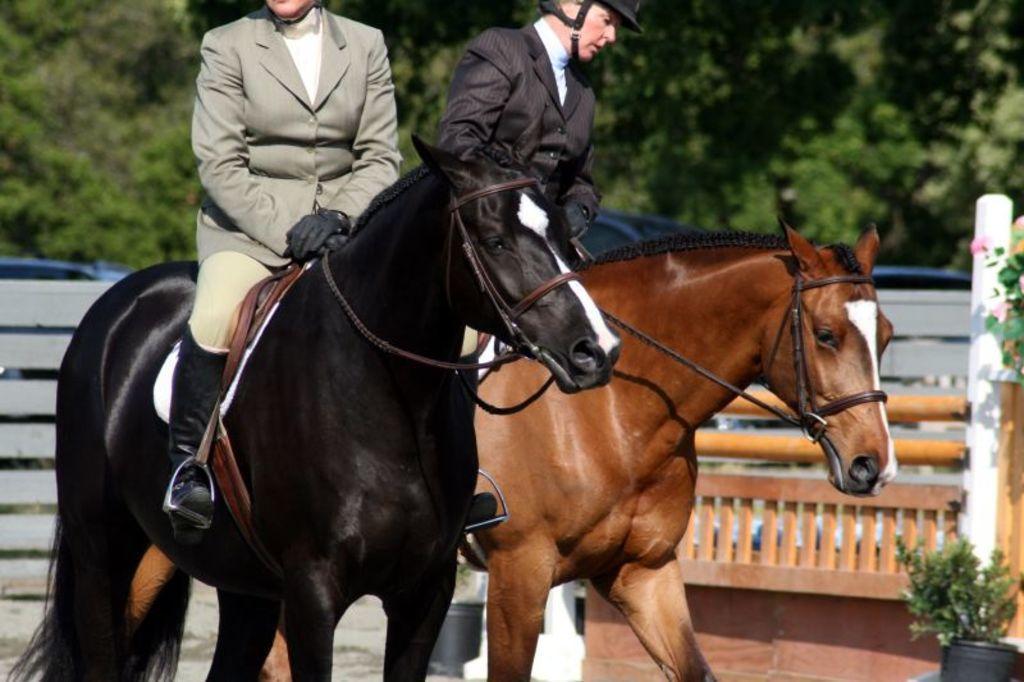Please provide a concise description of this image. In this image we can see these persons wearing blazers, gloves, helmets and long boots are sitting on the horse. The background of the image is slightly blurred, where we can see flower pots and trees. 